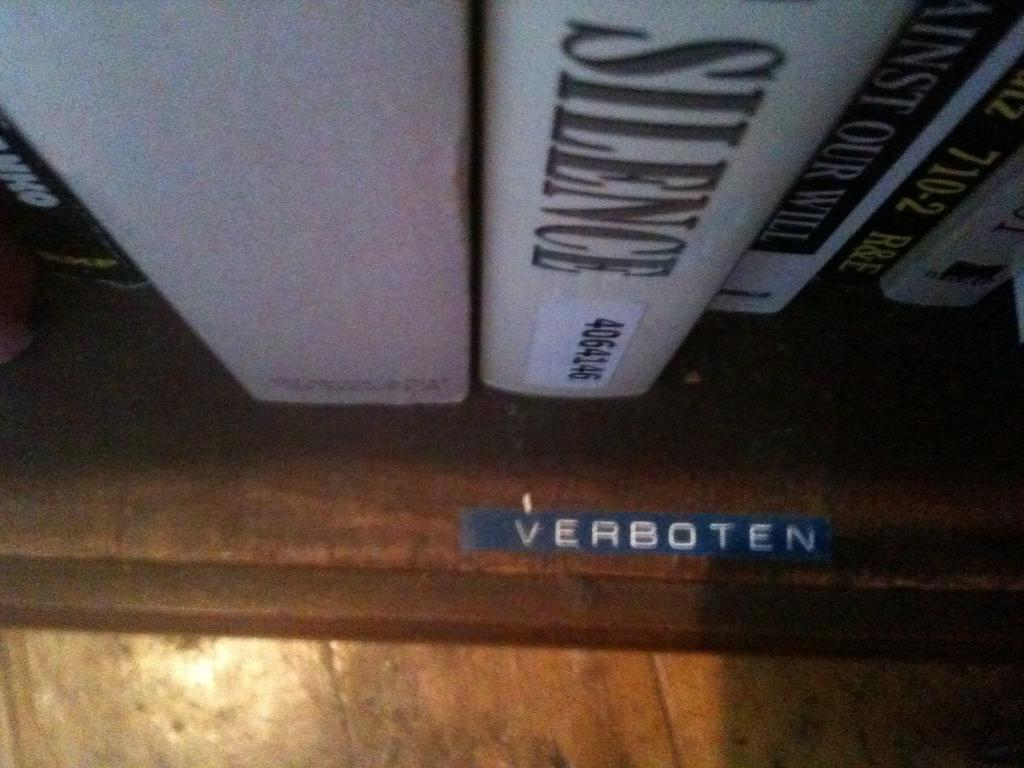<image>
Relay a brief, clear account of the picture shown. A shelf with a variety of books with a blue label on the shelf that says Verboten. 